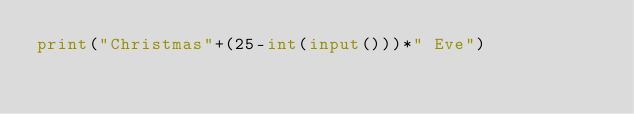Convert code to text. <code><loc_0><loc_0><loc_500><loc_500><_Python_>print("Christmas"+(25-int(input()))*" Eve")</code> 